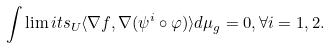Convert formula to latex. <formula><loc_0><loc_0><loc_500><loc_500>\int \lim i t s _ { U } \langle \nabla f , \nabla ( \psi ^ { i } \circ \varphi ) \rangle d \mu _ { g } = 0 , \forall i = 1 , 2 .</formula> 